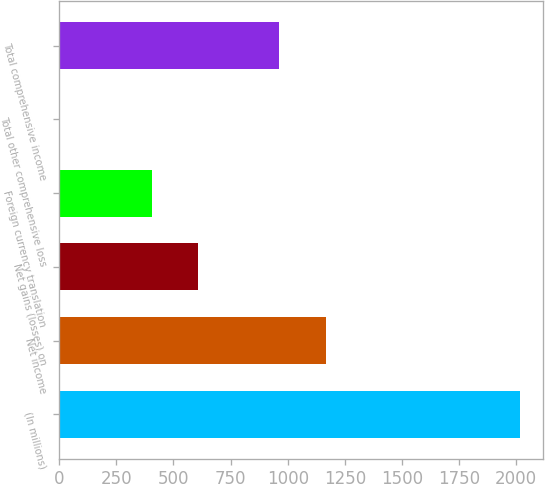Convert chart. <chart><loc_0><loc_0><loc_500><loc_500><bar_chart><fcel>(In millions)<fcel>Net income<fcel>Net gains (losses) on<fcel>Foreign currency translation<fcel>Total other comprehensive loss<fcel>Total comprehensive income<nl><fcel>2017<fcel>1165.4<fcel>607.2<fcel>405.8<fcel>3<fcel>964<nl></chart> 